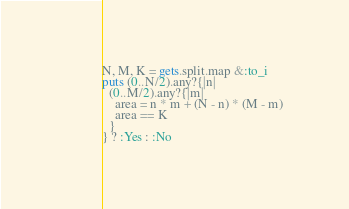<code> <loc_0><loc_0><loc_500><loc_500><_Ruby_>N, M, K = gets.split.map &:to_i
puts (0..N/2).any?{|n|
  (0..M/2).any?{|m|
    area = n * m + (N - n) * (M - m)
    area == K
  }
} ? :Yes : :No</code> 